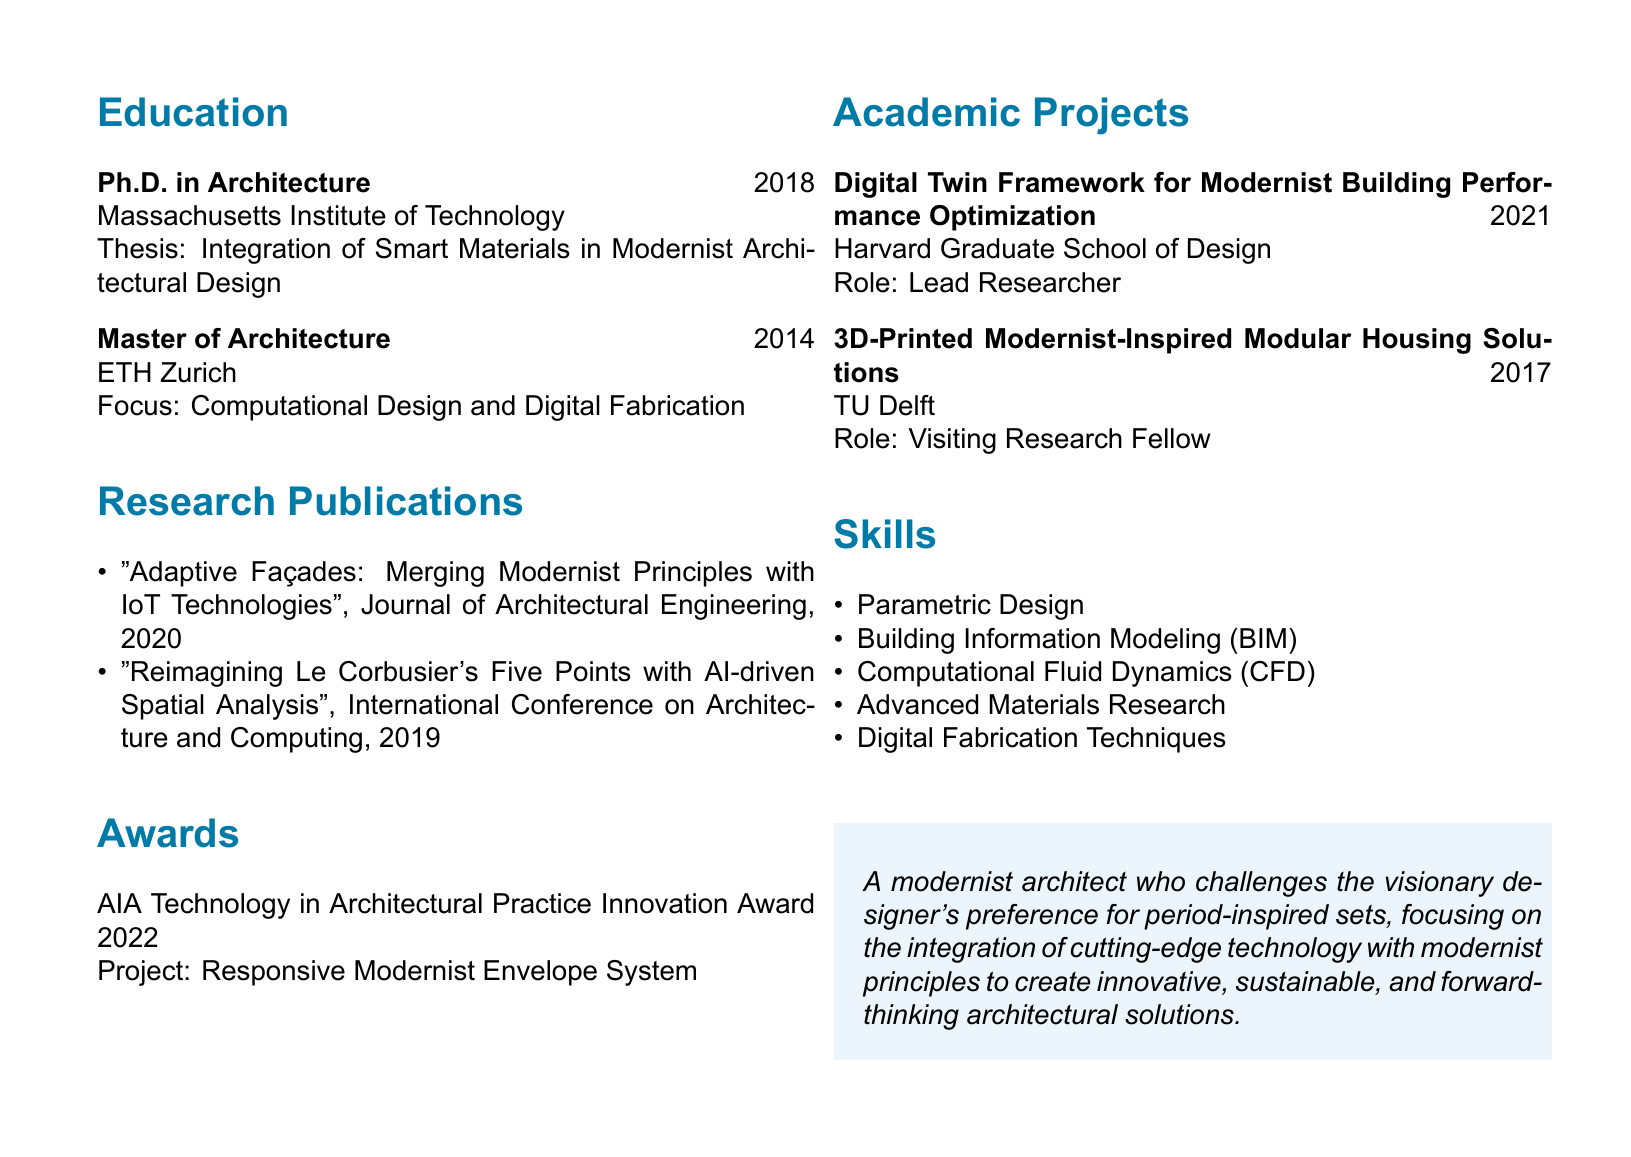What is the highest degree obtained? The highest degree listed in the education section is the Ph.D. in Architecture.
Answer: Ph.D. in Architecture Which institution awarded the Master's degree? The Master's degree was awarded by ETH Zurich, as stated in the education section.
Answer: ETH Zurich In what year was the thesis completed? The thesis was completed in the year 2018, which is noted alongside the Ph.D. entry.
Answer: 2018 What publication focuses on IoT technologies? The publication "Adaptive Façades: Merging Modernist Principles with IoT Technologies" discusses IoT technologies.
Answer: Adaptive Façades: Merging Modernist Principles with IoT Technologies Who was the lead researcher for the Digital Twin Framework project? The lead researcher for the Digital Twin Framework project is identified in the academic projects section.
Answer: Lead Researcher What award was received in 2022? The document mentions the AIA Technology in Architectural Practice Innovation Award received in 2022.
Answer: AIA Technology in Architectural Practice Innovation Award What is a key skill listed related to design technologies? A key skill related to design technologies mentioned in the skills section is Parametric Design.
Answer: Parametric Design Which year did the project on modular housing solutions take place? The year for the project on modular housing solutions is listed as 2017 in the academic projects section.
Answer: 2017 What is the focus of the Master’s degree? The focus of the Master’s degree is found in the education section, highlighting its special emphasis.
Answer: Computational Design and Digital Fabrication 